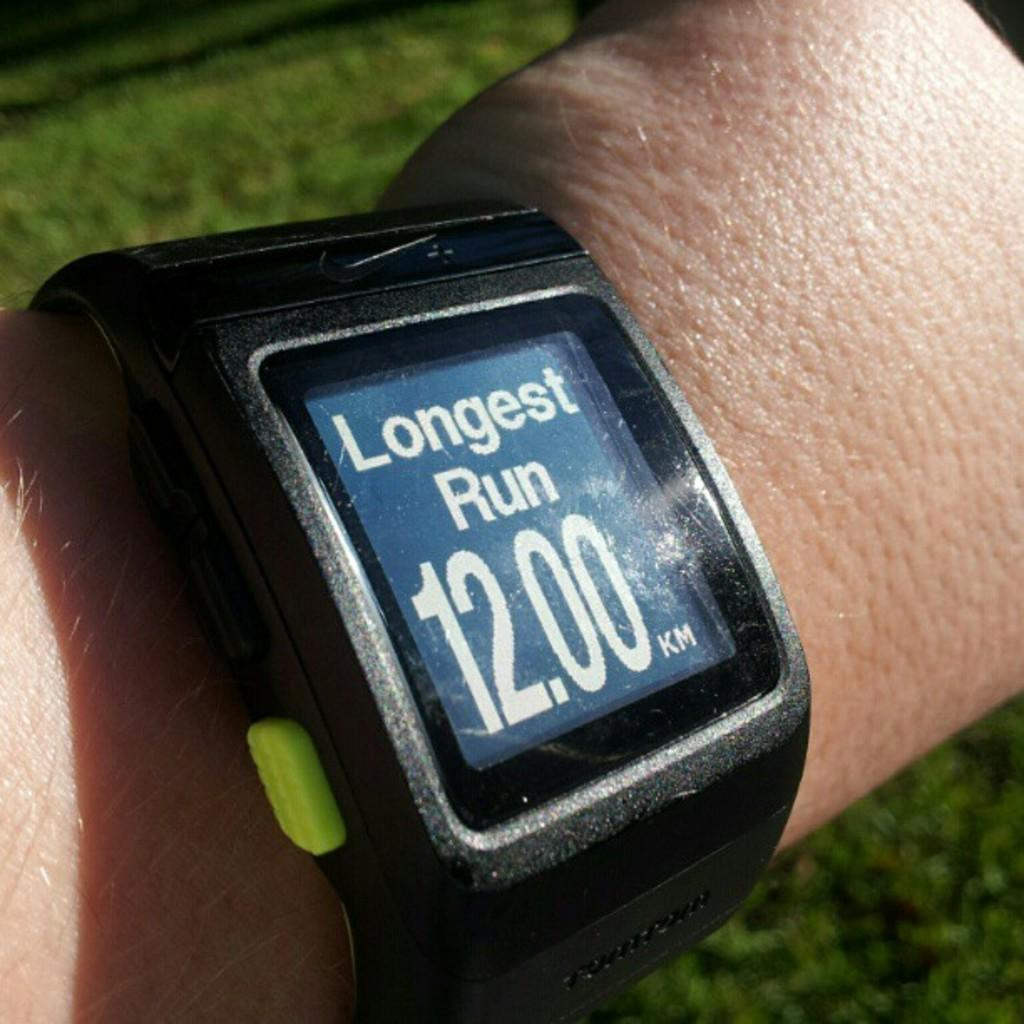<image>
Share a concise interpretation of the image provided. The watch says that the longest run was 12.00 Kilometers 